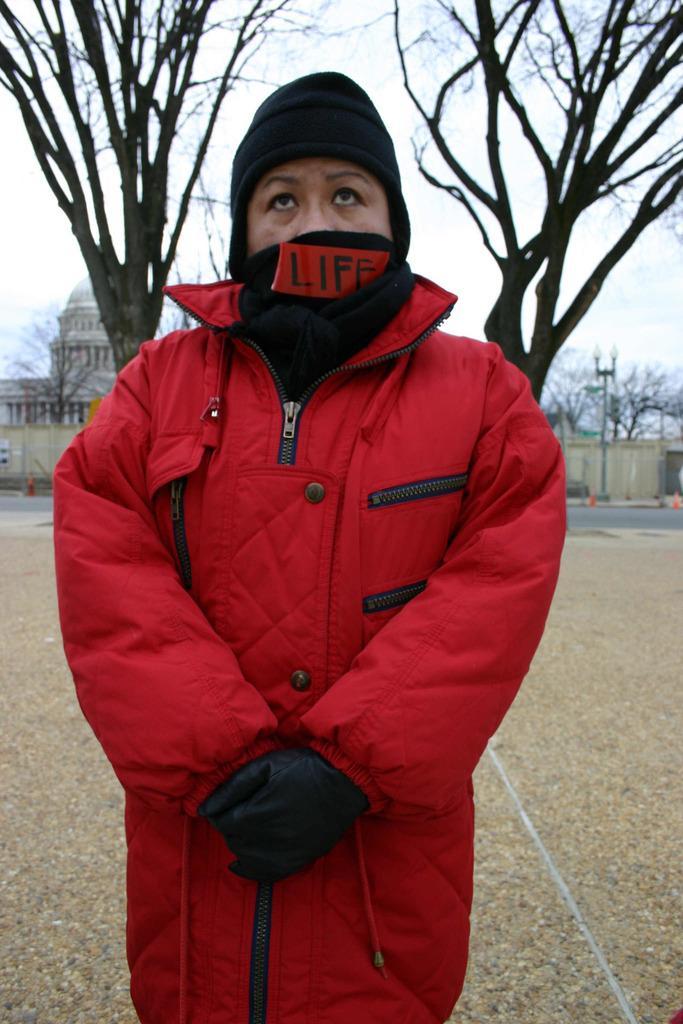Could you give a brief overview of what you see in this image? In this image there is a person standing wearing a jacket and mask standing on land, in the background there are trees, buildings and the sky. 